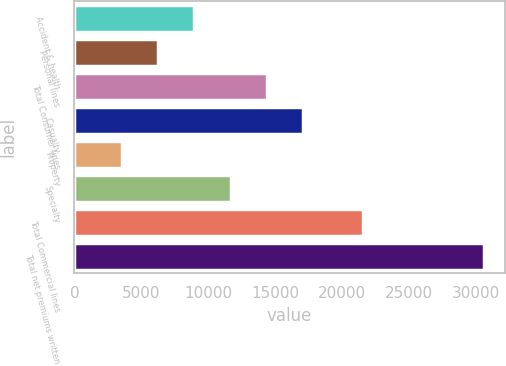<chart> <loc_0><loc_0><loc_500><loc_500><bar_chart><fcel>Accident & health<fcel>Personal lines<fcel>Total Consumer lines<fcel>Casualty<fcel>Property<fcel>Specialty<fcel>Total Commercial lines<fcel>Total net premiums written<nl><fcel>8969<fcel>6258.5<fcel>14390<fcel>17100.5<fcel>3548<fcel>11679.5<fcel>21592<fcel>30653<nl></chart> 